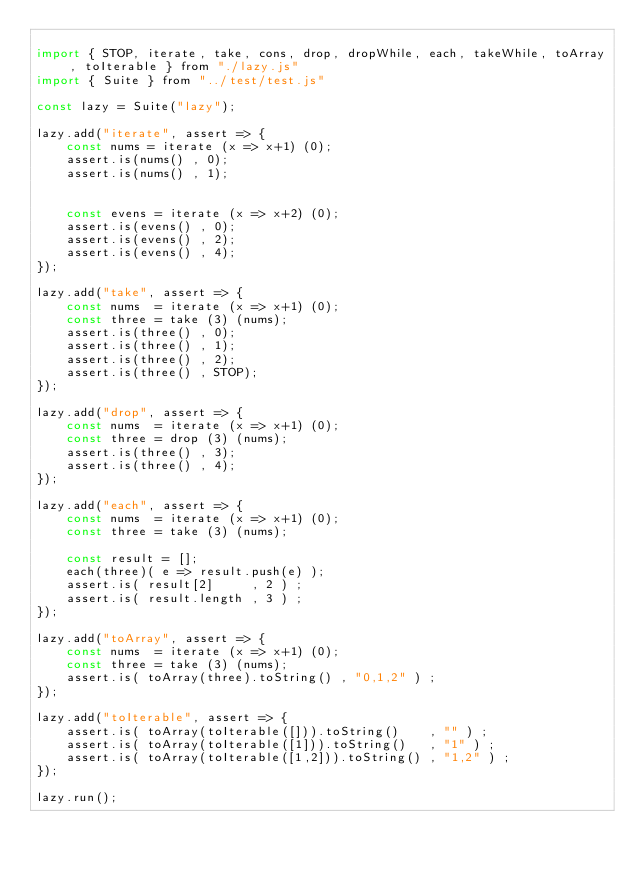<code> <loc_0><loc_0><loc_500><loc_500><_JavaScript_>
import { STOP, iterate, take, cons, drop, dropWhile, each, takeWhile, toArray, toIterable } from "./lazy.js"
import { Suite } from "../test/test.js"

const lazy = Suite("lazy");

lazy.add("iterate", assert => {
    const nums = iterate (x => x+1) (0);
    assert.is(nums() , 0);
    assert.is(nums() , 1);


    const evens = iterate (x => x+2) (0);
    assert.is(evens() , 0);
    assert.is(evens() , 2);
    assert.is(evens() , 4);
});

lazy.add("take", assert => {
    const nums  = iterate (x => x+1) (0);
    const three = take (3) (nums);
    assert.is(three() , 0);
    assert.is(three() , 1);
    assert.is(three() , 2);
    assert.is(three() , STOP);
});

lazy.add("drop", assert => {
    const nums  = iterate (x => x+1) (0);
    const three = drop (3) (nums);
    assert.is(three() , 3);
    assert.is(three() , 4);
});

lazy.add("each", assert => {
    const nums  = iterate (x => x+1) (0);
    const three = take (3) (nums);

    const result = [];
    each(three)( e => result.push(e) );
    assert.is( result[2]     , 2 ) ;
    assert.is( result.length , 3 ) ;
});

lazy.add("toArray", assert => {
    const nums  = iterate (x => x+1) (0);
    const three = take (3) (nums);
    assert.is( toArray(three).toString() , "0,1,2" ) ;
});

lazy.add("toIterable", assert => {
    assert.is( toArray(toIterable([])).toString()    , "" ) ;
    assert.is( toArray(toIterable([1])).toString()   , "1" ) ;
    assert.is( toArray(toIterable([1,2])).toString() , "1,2" ) ;
});

lazy.run();</code> 